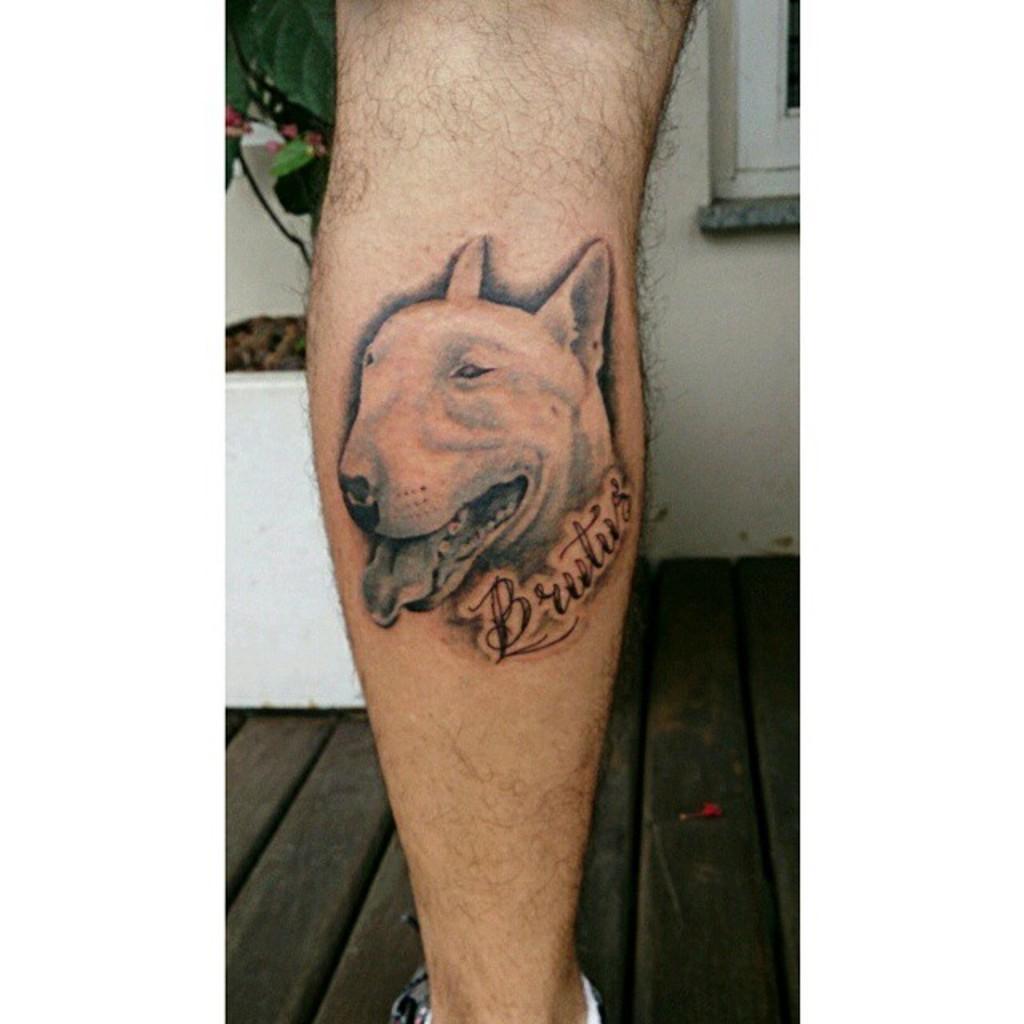Describe this image in one or two sentences. In this image we can see tattoo of a dog on some person's hand and in the background of the image there is plant and a wall. 